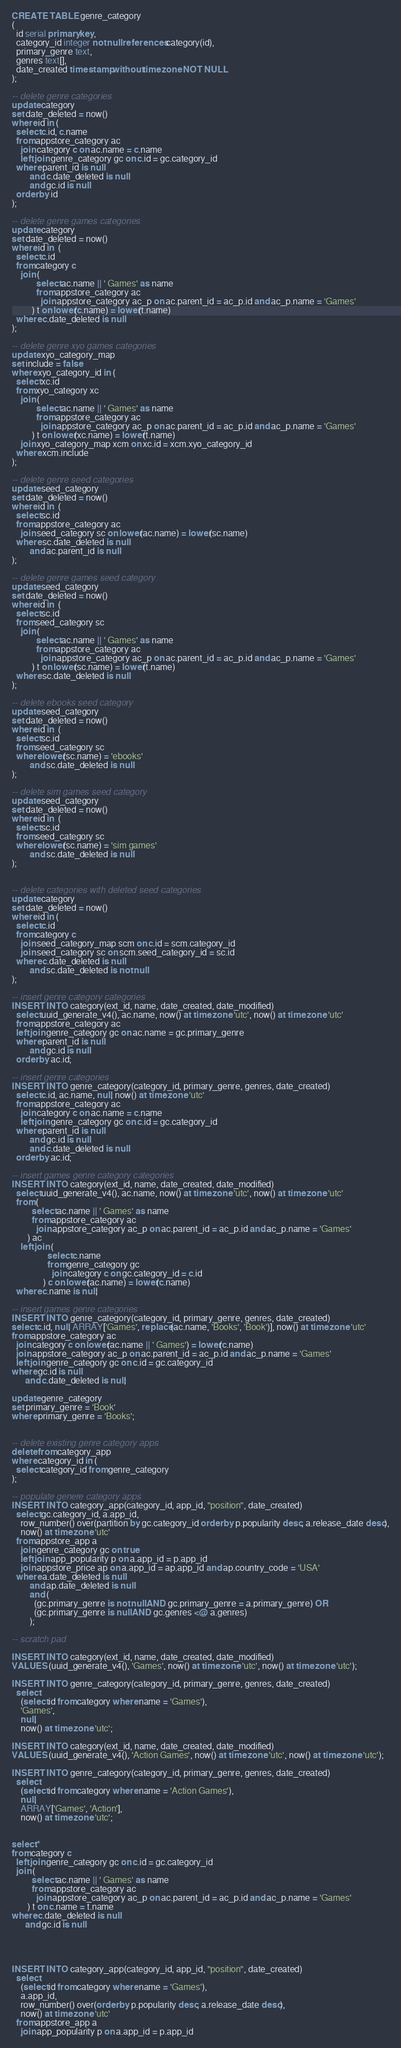Convert code to text. <code><loc_0><loc_0><loc_500><loc_500><_SQL_>CREATE TABLE genre_category
(
  id serial primary key,
  category_id integer not null references category(id),
  primary_genre text,
  genres text[],
  date_created timestamp without time zone NOT NULL
);

-- delete genre categories
update category
set date_deleted = now()
where id in (
  select c.id, c.name
  from appstore_category ac
    join category c on ac.name = c.name
    left join genre_category gc on c.id = gc.category_id
  where parent_id is null
        and c.date_deleted is null
        and gc.id is null
  order by id
);

-- delete genre games categories
update category
set date_deleted = now()
where id in  (
  select c.id
  from category c
    join (
           select ac.name || ' Games' as name
           from appstore_category ac
             join appstore_category ac_p on ac.parent_id = ac_p.id and ac_p.name = 'Games'
         ) t on lower(c.name) = lower(t.name)
  where c.date_deleted is null
);

-- delete genre xyo games categories
update xyo_category_map
set include = false
where xyo_category_id in (
  select xc.id
  from xyo_category xc
    join (
           select ac.name || ' Games' as name
           from appstore_category ac
             join appstore_category ac_p on ac.parent_id = ac_p.id and ac_p.name = 'Games'
         ) t on lower(xc.name) = lower(t.name)
    join xyo_category_map xcm on xc.id = xcm.xyo_category_id
  where xcm.include
);

-- delete genre seed categories
update seed_category
set date_deleted = now()
where id in  (
  select sc.id
  from appstore_category ac
    join seed_category sc on lower(ac.name) = lower(sc.name)
  where sc.date_deleted is null
        and ac.parent_id is null
);

-- delete genre games seed category
update seed_category
set date_deleted = now()
where id in  (
  select sc.id
  from seed_category sc
    join (
           select ac.name || ' Games' as name
           from appstore_category ac
             join appstore_category ac_p on ac.parent_id = ac_p.id and ac_p.name = 'Games'
         ) t on lower(sc.name) = lower(t.name)
  where sc.date_deleted is null
);

-- delete ebooks seed category
update seed_category
set date_deleted = now()
where id in  (
  select sc.id
  from seed_category sc
  where lower(sc.name) = 'ebooks'
        and sc.date_deleted is null
);

-- delete sim games seed category
update seed_category
set date_deleted = now()
where id in  (
  select sc.id
  from seed_category sc
  where lower(sc.name) = 'sim games'
        and sc.date_deleted is null
);


-- delete categories with deleted seed categories
update category
set date_deleted = now()
where id in (
  select c.id
  from category c
    join seed_category_map scm on c.id = scm.category_id
    join seed_category sc on scm.seed_category_id = sc.id
  where c.date_deleted is null
        and sc.date_deleted is not null
);

-- insert genre category categories
INSERT INTO category(ext_id, name, date_created, date_modified)
  select uuid_generate_v4(), ac.name, now() at time zone 'utc', now() at time zone 'utc'
  from appstore_category ac
  left join genre_category gc on ac.name = gc.primary_genre
  where parent_id is null
        and gc.id is null
  order by ac.id;

-- insert genre categories
INSERT INTO genre_category(category_id, primary_genre, genres, date_created)
  select c.id, ac.name, null, now() at time zone 'utc'
  from appstore_category ac
    join category c on ac.name = c.name
    left join genre_category gc on c.id = gc.category_id
  where parent_id is null
        and gc.id is null
        and c.date_deleted is null
  order by ac.id;

-- insert games genre category categories
INSERT INTO category(ext_id, name, date_created, date_modified)
  select uuid_generate_v4(), ac.name, now() at time zone 'utc', now() at time zone 'utc'
  from (
         select ac.name || ' Games' as name
         from appstore_category ac
           join appstore_category ac_p on ac.parent_id = ac_p.id and ac_p.name = 'Games'
       ) ac
    left join (
                select c.name
                from genre_category gc
                  join category c on gc.category_id = c.id
              ) c on lower(ac.name) = lower(c.name)
  where c.name is null;

-- insert games genre categories
INSERT INTO genre_category(category_id, primary_genre, genres, date_created)
select c.id, null, ARRAY['Games', replace(ac.name, 'Books', 'Book')], now() at time zone 'utc'
from appstore_category ac
  join category c on lower(ac.name || ' Games') = lower(c.name)
  join appstore_category ac_p on ac.parent_id = ac_p.id and ac_p.name = 'Games'
  left join genre_category gc on c.id = gc.category_id
where gc.id is null
      and c.date_deleted is null;

update genre_category
set primary_genre = 'Book'
where primary_genre = 'Books';


-- delete existing genre category apps
delete from category_app
where category_id in (
  select category_id from genre_category
);

-- populate genere category apps
INSERT INTO category_app(category_id, app_id, "position", date_created)
  select gc.category_id, a.app_id,
    row_number() over(partition by gc.category_id order by p.popularity desc, a.release_date desc),
    now() at time zone 'utc'
  from appstore_app a
    join genre_category gc on true
    left join app_popularity p on a.app_id = p.app_id
    join appstore_price ap on a.app_id = ap.app_id and ap.country_code = 'USA'
  where a.date_deleted is null
        and ap.date_deleted is null
        and (
          (gc.primary_genre is not null AND gc.primary_genre = a.primary_genre) OR
          (gc.primary_genre is null AND gc.genres <@ a.genres)
        );

-- scratch pad

INSERT INTO category(ext_id, name, date_created, date_modified)
VALUES (uuid_generate_v4(), 'Games', now() at time zone 'utc', now() at time zone 'utc');

INSERT INTO genre_category(category_id, primary_genre, genres, date_created)
  select
    (select id from category where name = 'Games'),
    'Games',
    null,
    now() at time zone 'utc';

INSERT INTO category(ext_id, name, date_created, date_modified)
VALUES (uuid_generate_v4(), 'Action Games', now() at time zone 'utc', now() at time zone 'utc');

INSERT INTO genre_category(category_id, primary_genre, genres, date_created)
  select
    (select id from category where name = 'Action Games'),
    null,
    ARRAY['Games', 'Action'],
    now() at time zone 'utc';


select *
from category c
  left join genre_category gc on c.id = gc.category_id
  join (
         select ac.name || ' Games' as name
         from appstore_category ac
           join appstore_category ac_p on ac.parent_id = ac_p.id and ac_p.name = 'Games'
       ) t on c.name = t.name
where c.date_deleted is null
      and gc.id is null




INSERT INTO category_app(category_id, app_id, "position", date_created)
  select
    (select id from category where name = 'Games'),
    a.app_id,
    row_number() over(order by p.popularity desc, a.release_date desc),
    now() at time zone 'utc'
  from appstore_app a
    join app_popularity p on a.app_id = p.app_id</code> 